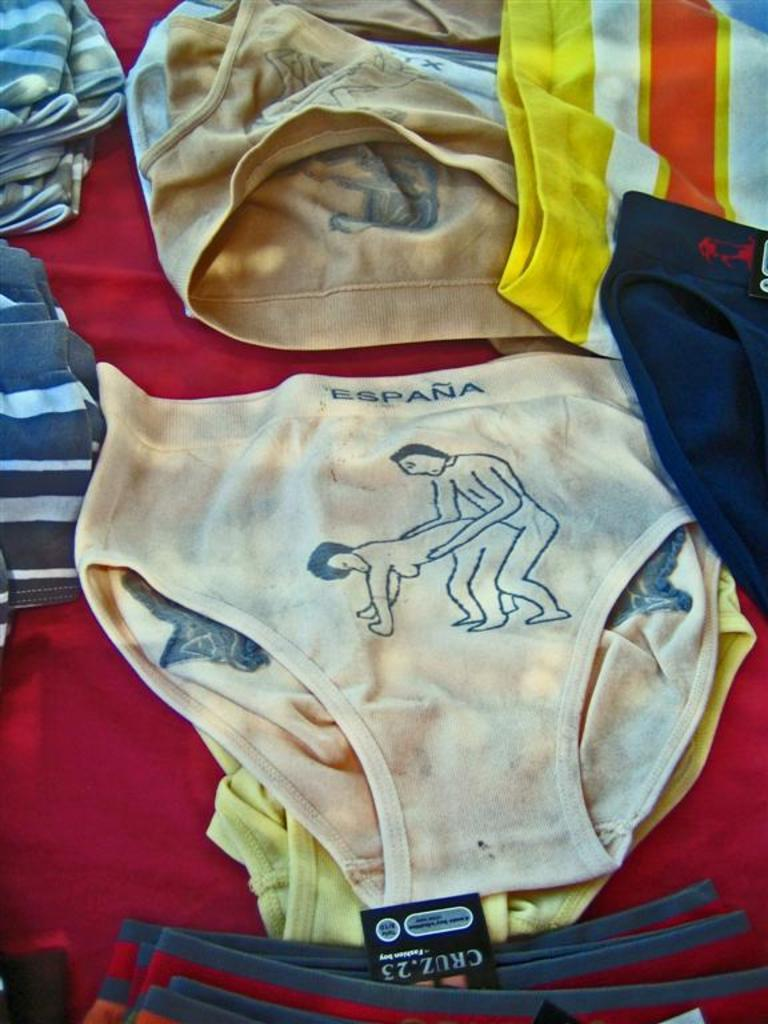<image>
Give a short and clear explanation of the subsequent image. A pair of underwear show two people wrestling below the word Espana. 